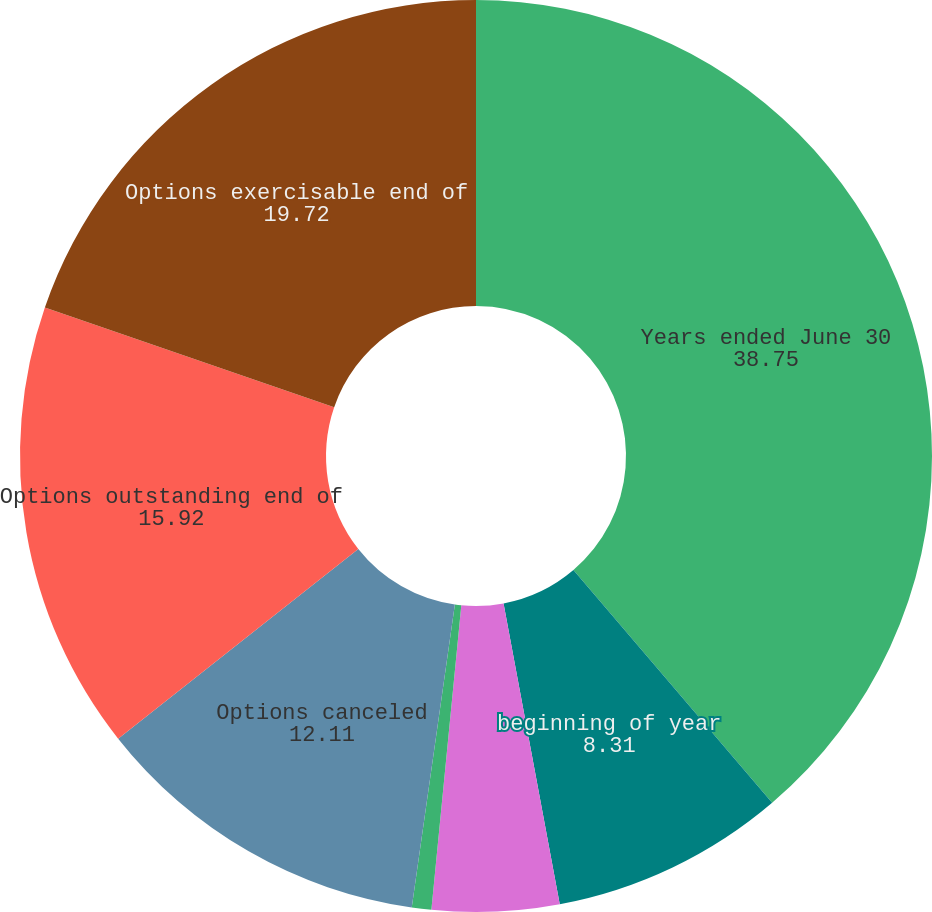Convert chart to OTSL. <chart><loc_0><loc_0><loc_500><loc_500><pie_chart><fcel>Years ended June 30<fcel>beginning of year<fcel>Options granted<fcel>Options exercised<fcel>Options canceled<fcel>Options outstanding end of<fcel>Options exercisable end of<nl><fcel>38.75%<fcel>8.31%<fcel>4.5%<fcel>0.69%<fcel>12.11%<fcel>15.92%<fcel>19.72%<nl></chart> 